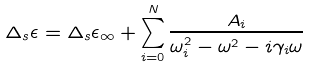<formula> <loc_0><loc_0><loc_500><loc_500>\Delta _ { s } \epsilon = \Delta _ { s } \epsilon _ { \infty } + \sum _ { i = 0 } ^ { N } \frac { A _ { i } } { \omega _ { i } ^ { 2 } - \omega ^ { 2 } - i \gamma _ { i } \omega }</formula> 